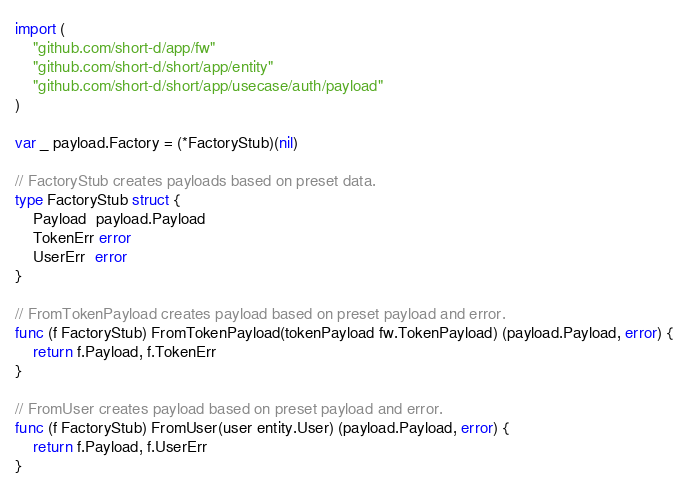Convert code to text. <code><loc_0><loc_0><loc_500><loc_500><_Go_>import (
	"github.com/short-d/app/fw"
	"github.com/short-d/short/app/entity"
	"github.com/short-d/short/app/usecase/auth/payload"
)

var _ payload.Factory = (*FactoryStub)(nil)

// FactoryStub creates payloads based on preset data.
type FactoryStub struct {
	Payload  payload.Payload
	TokenErr error
	UserErr  error
}

// FromTokenPayload creates payload based on preset payload and error.
func (f FactoryStub) FromTokenPayload(tokenPayload fw.TokenPayload) (payload.Payload, error) {
	return f.Payload, f.TokenErr
}

// FromUser creates payload based on preset payload and error.
func (f FactoryStub) FromUser(user entity.User) (payload.Payload, error) {
	return f.Payload, f.UserErr
}
</code> 